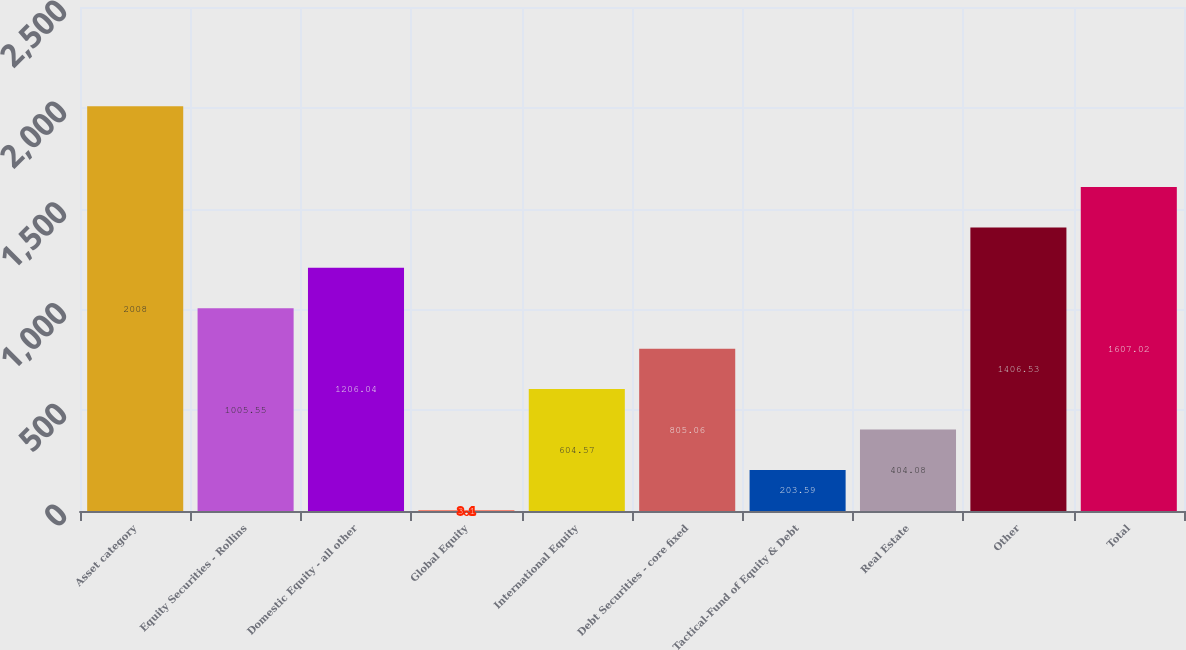<chart> <loc_0><loc_0><loc_500><loc_500><bar_chart><fcel>Asset category<fcel>Equity Securities - Rollins<fcel>Domestic Equity - all other<fcel>Global Equity<fcel>International Equity<fcel>Debt Securities - core fixed<fcel>Tactical-Fund of Equity & Debt<fcel>Real Estate<fcel>Other<fcel>Total<nl><fcel>2008<fcel>1005.55<fcel>1206.04<fcel>3.1<fcel>604.57<fcel>805.06<fcel>203.59<fcel>404.08<fcel>1406.53<fcel>1607.02<nl></chart> 